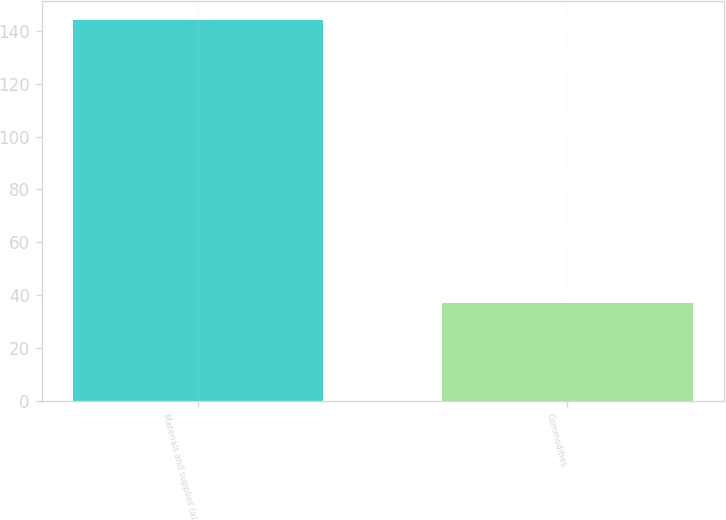Convert chart. <chart><loc_0><loc_0><loc_500><loc_500><bar_chart><fcel>Materials and supplies (a)<fcel>Commodities<nl><fcel>144<fcel>37<nl></chart> 